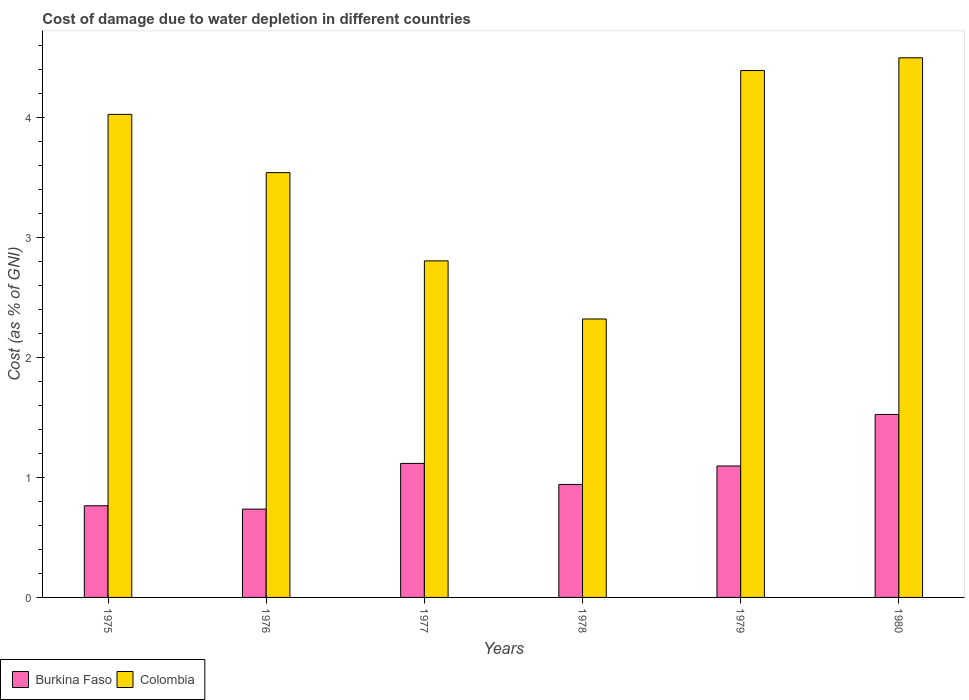Are the number of bars per tick equal to the number of legend labels?
Provide a short and direct response. Yes. Are the number of bars on each tick of the X-axis equal?
Make the answer very short. Yes. How many bars are there on the 1st tick from the left?
Provide a short and direct response. 2. What is the label of the 5th group of bars from the left?
Keep it short and to the point. 1979. In how many cases, is the number of bars for a given year not equal to the number of legend labels?
Your answer should be compact. 0. What is the cost of damage caused due to water depletion in Burkina Faso in 1977?
Ensure brevity in your answer.  1.12. Across all years, what is the maximum cost of damage caused due to water depletion in Burkina Faso?
Make the answer very short. 1.52. Across all years, what is the minimum cost of damage caused due to water depletion in Colombia?
Offer a terse response. 2.32. In which year was the cost of damage caused due to water depletion in Burkina Faso minimum?
Your response must be concise. 1976. What is the total cost of damage caused due to water depletion in Burkina Faso in the graph?
Give a very brief answer. 6.17. What is the difference between the cost of damage caused due to water depletion in Colombia in 1975 and that in 1977?
Offer a very short reply. 1.22. What is the difference between the cost of damage caused due to water depletion in Burkina Faso in 1976 and the cost of damage caused due to water depletion in Colombia in 1980?
Offer a terse response. -3.76. What is the average cost of damage caused due to water depletion in Colombia per year?
Your response must be concise. 3.59. In the year 1979, what is the difference between the cost of damage caused due to water depletion in Colombia and cost of damage caused due to water depletion in Burkina Faso?
Offer a terse response. 3.29. In how many years, is the cost of damage caused due to water depletion in Colombia greater than 3.4 %?
Your answer should be compact. 4. What is the ratio of the cost of damage caused due to water depletion in Colombia in 1979 to that in 1980?
Provide a short and direct response. 0.98. Is the difference between the cost of damage caused due to water depletion in Colombia in 1979 and 1980 greater than the difference between the cost of damage caused due to water depletion in Burkina Faso in 1979 and 1980?
Ensure brevity in your answer.  Yes. What is the difference between the highest and the second highest cost of damage caused due to water depletion in Colombia?
Provide a short and direct response. 0.11. What is the difference between the highest and the lowest cost of damage caused due to water depletion in Burkina Faso?
Keep it short and to the point. 0.79. In how many years, is the cost of damage caused due to water depletion in Burkina Faso greater than the average cost of damage caused due to water depletion in Burkina Faso taken over all years?
Offer a very short reply. 3. Is the sum of the cost of damage caused due to water depletion in Colombia in 1975 and 1976 greater than the maximum cost of damage caused due to water depletion in Burkina Faso across all years?
Your answer should be compact. Yes. What does the 1st bar from the left in 1977 represents?
Make the answer very short. Burkina Faso. Does the graph contain grids?
Ensure brevity in your answer.  No. Where does the legend appear in the graph?
Provide a short and direct response. Bottom left. How many legend labels are there?
Provide a short and direct response. 2. How are the legend labels stacked?
Your response must be concise. Horizontal. What is the title of the graph?
Make the answer very short. Cost of damage due to water depletion in different countries. Does "Slovenia" appear as one of the legend labels in the graph?
Give a very brief answer. No. What is the label or title of the X-axis?
Make the answer very short. Years. What is the label or title of the Y-axis?
Provide a succinct answer. Cost (as % of GNI). What is the Cost (as % of GNI) of Burkina Faso in 1975?
Keep it short and to the point. 0.76. What is the Cost (as % of GNI) of Colombia in 1975?
Ensure brevity in your answer.  4.02. What is the Cost (as % of GNI) of Burkina Faso in 1976?
Ensure brevity in your answer.  0.74. What is the Cost (as % of GNI) in Colombia in 1976?
Give a very brief answer. 3.54. What is the Cost (as % of GNI) in Burkina Faso in 1977?
Your answer should be very brief. 1.12. What is the Cost (as % of GNI) of Colombia in 1977?
Your answer should be compact. 2.8. What is the Cost (as % of GNI) in Burkina Faso in 1978?
Your answer should be very brief. 0.94. What is the Cost (as % of GNI) of Colombia in 1978?
Provide a short and direct response. 2.32. What is the Cost (as % of GNI) of Burkina Faso in 1979?
Make the answer very short. 1.09. What is the Cost (as % of GNI) in Colombia in 1979?
Make the answer very short. 4.39. What is the Cost (as % of GNI) in Burkina Faso in 1980?
Provide a succinct answer. 1.52. What is the Cost (as % of GNI) in Colombia in 1980?
Provide a succinct answer. 4.49. Across all years, what is the maximum Cost (as % of GNI) of Burkina Faso?
Give a very brief answer. 1.52. Across all years, what is the maximum Cost (as % of GNI) in Colombia?
Provide a short and direct response. 4.49. Across all years, what is the minimum Cost (as % of GNI) of Burkina Faso?
Offer a very short reply. 0.74. Across all years, what is the minimum Cost (as % of GNI) in Colombia?
Your answer should be very brief. 2.32. What is the total Cost (as % of GNI) in Burkina Faso in the graph?
Your answer should be very brief. 6.17. What is the total Cost (as % of GNI) in Colombia in the graph?
Your answer should be very brief. 21.56. What is the difference between the Cost (as % of GNI) in Burkina Faso in 1975 and that in 1976?
Make the answer very short. 0.03. What is the difference between the Cost (as % of GNI) of Colombia in 1975 and that in 1976?
Your answer should be very brief. 0.49. What is the difference between the Cost (as % of GNI) of Burkina Faso in 1975 and that in 1977?
Offer a terse response. -0.35. What is the difference between the Cost (as % of GNI) of Colombia in 1975 and that in 1977?
Provide a short and direct response. 1.22. What is the difference between the Cost (as % of GNI) of Burkina Faso in 1975 and that in 1978?
Provide a short and direct response. -0.18. What is the difference between the Cost (as % of GNI) of Colombia in 1975 and that in 1978?
Give a very brief answer. 1.7. What is the difference between the Cost (as % of GNI) of Burkina Faso in 1975 and that in 1979?
Make the answer very short. -0.33. What is the difference between the Cost (as % of GNI) of Colombia in 1975 and that in 1979?
Make the answer very short. -0.36. What is the difference between the Cost (as % of GNI) in Burkina Faso in 1975 and that in 1980?
Provide a short and direct response. -0.76. What is the difference between the Cost (as % of GNI) in Colombia in 1975 and that in 1980?
Provide a succinct answer. -0.47. What is the difference between the Cost (as % of GNI) of Burkina Faso in 1976 and that in 1977?
Provide a short and direct response. -0.38. What is the difference between the Cost (as % of GNI) in Colombia in 1976 and that in 1977?
Make the answer very short. 0.73. What is the difference between the Cost (as % of GNI) in Burkina Faso in 1976 and that in 1978?
Your response must be concise. -0.21. What is the difference between the Cost (as % of GNI) of Colombia in 1976 and that in 1978?
Ensure brevity in your answer.  1.22. What is the difference between the Cost (as % of GNI) in Burkina Faso in 1976 and that in 1979?
Offer a terse response. -0.36. What is the difference between the Cost (as % of GNI) of Colombia in 1976 and that in 1979?
Make the answer very short. -0.85. What is the difference between the Cost (as % of GNI) in Burkina Faso in 1976 and that in 1980?
Provide a succinct answer. -0.79. What is the difference between the Cost (as % of GNI) of Colombia in 1976 and that in 1980?
Offer a very short reply. -0.96. What is the difference between the Cost (as % of GNI) in Burkina Faso in 1977 and that in 1978?
Ensure brevity in your answer.  0.18. What is the difference between the Cost (as % of GNI) in Colombia in 1977 and that in 1978?
Give a very brief answer. 0.48. What is the difference between the Cost (as % of GNI) of Burkina Faso in 1977 and that in 1979?
Provide a short and direct response. 0.02. What is the difference between the Cost (as % of GNI) in Colombia in 1977 and that in 1979?
Make the answer very short. -1.58. What is the difference between the Cost (as % of GNI) in Burkina Faso in 1977 and that in 1980?
Make the answer very short. -0.41. What is the difference between the Cost (as % of GNI) of Colombia in 1977 and that in 1980?
Offer a terse response. -1.69. What is the difference between the Cost (as % of GNI) of Burkina Faso in 1978 and that in 1979?
Ensure brevity in your answer.  -0.15. What is the difference between the Cost (as % of GNI) in Colombia in 1978 and that in 1979?
Ensure brevity in your answer.  -2.07. What is the difference between the Cost (as % of GNI) in Burkina Faso in 1978 and that in 1980?
Your response must be concise. -0.58. What is the difference between the Cost (as % of GNI) of Colombia in 1978 and that in 1980?
Your response must be concise. -2.17. What is the difference between the Cost (as % of GNI) of Burkina Faso in 1979 and that in 1980?
Keep it short and to the point. -0.43. What is the difference between the Cost (as % of GNI) of Colombia in 1979 and that in 1980?
Offer a very short reply. -0.11. What is the difference between the Cost (as % of GNI) of Burkina Faso in 1975 and the Cost (as % of GNI) of Colombia in 1976?
Make the answer very short. -2.77. What is the difference between the Cost (as % of GNI) of Burkina Faso in 1975 and the Cost (as % of GNI) of Colombia in 1977?
Keep it short and to the point. -2.04. What is the difference between the Cost (as % of GNI) of Burkina Faso in 1975 and the Cost (as % of GNI) of Colombia in 1978?
Keep it short and to the point. -1.56. What is the difference between the Cost (as % of GNI) of Burkina Faso in 1975 and the Cost (as % of GNI) of Colombia in 1979?
Your answer should be very brief. -3.62. What is the difference between the Cost (as % of GNI) in Burkina Faso in 1975 and the Cost (as % of GNI) in Colombia in 1980?
Your response must be concise. -3.73. What is the difference between the Cost (as % of GNI) of Burkina Faso in 1976 and the Cost (as % of GNI) of Colombia in 1977?
Offer a terse response. -2.07. What is the difference between the Cost (as % of GNI) of Burkina Faso in 1976 and the Cost (as % of GNI) of Colombia in 1978?
Give a very brief answer. -1.58. What is the difference between the Cost (as % of GNI) in Burkina Faso in 1976 and the Cost (as % of GNI) in Colombia in 1979?
Offer a very short reply. -3.65. What is the difference between the Cost (as % of GNI) in Burkina Faso in 1976 and the Cost (as % of GNI) in Colombia in 1980?
Your answer should be compact. -3.76. What is the difference between the Cost (as % of GNI) of Burkina Faso in 1977 and the Cost (as % of GNI) of Colombia in 1978?
Offer a terse response. -1.2. What is the difference between the Cost (as % of GNI) of Burkina Faso in 1977 and the Cost (as % of GNI) of Colombia in 1979?
Make the answer very short. -3.27. What is the difference between the Cost (as % of GNI) in Burkina Faso in 1977 and the Cost (as % of GNI) in Colombia in 1980?
Your response must be concise. -3.38. What is the difference between the Cost (as % of GNI) of Burkina Faso in 1978 and the Cost (as % of GNI) of Colombia in 1979?
Provide a succinct answer. -3.45. What is the difference between the Cost (as % of GNI) in Burkina Faso in 1978 and the Cost (as % of GNI) in Colombia in 1980?
Ensure brevity in your answer.  -3.55. What is the difference between the Cost (as % of GNI) in Burkina Faso in 1979 and the Cost (as % of GNI) in Colombia in 1980?
Give a very brief answer. -3.4. What is the average Cost (as % of GNI) of Burkina Faso per year?
Keep it short and to the point. 1.03. What is the average Cost (as % of GNI) in Colombia per year?
Your response must be concise. 3.59. In the year 1975, what is the difference between the Cost (as % of GNI) of Burkina Faso and Cost (as % of GNI) of Colombia?
Make the answer very short. -3.26. In the year 1976, what is the difference between the Cost (as % of GNI) of Burkina Faso and Cost (as % of GNI) of Colombia?
Your response must be concise. -2.8. In the year 1977, what is the difference between the Cost (as % of GNI) of Burkina Faso and Cost (as % of GNI) of Colombia?
Provide a succinct answer. -1.69. In the year 1978, what is the difference between the Cost (as % of GNI) of Burkina Faso and Cost (as % of GNI) of Colombia?
Ensure brevity in your answer.  -1.38. In the year 1979, what is the difference between the Cost (as % of GNI) in Burkina Faso and Cost (as % of GNI) in Colombia?
Provide a succinct answer. -3.29. In the year 1980, what is the difference between the Cost (as % of GNI) of Burkina Faso and Cost (as % of GNI) of Colombia?
Your answer should be compact. -2.97. What is the ratio of the Cost (as % of GNI) in Burkina Faso in 1975 to that in 1976?
Make the answer very short. 1.04. What is the ratio of the Cost (as % of GNI) of Colombia in 1975 to that in 1976?
Give a very brief answer. 1.14. What is the ratio of the Cost (as % of GNI) in Burkina Faso in 1975 to that in 1977?
Provide a succinct answer. 0.68. What is the ratio of the Cost (as % of GNI) of Colombia in 1975 to that in 1977?
Your response must be concise. 1.44. What is the ratio of the Cost (as % of GNI) in Burkina Faso in 1975 to that in 1978?
Keep it short and to the point. 0.81. What is the ratio of the Cost (as % of GNI) in Colombia in 1975 to that in 1978?
Offer a very short reply. 1.73. What is the ratio of the Cost (as % of GNI) in Burkina Faso in 1975 to that in 1979?
Your answer should be very brief. 0.7. What is the ratio of the Cost (as % of GNI) of Colombia in 1975 to that in 1979?
Make the answer very short. 0.92. What is the ratio of the Cost (as % of GNI) in Burkina Faso in 1975 to that in 1980?
Provide a succinct answer. 0.5. What is the ratio of the Cost (as % of GNI) in Colombia in 1975 to that in 1980?
Your answer should be very brief. 0.9. What is the ratio of the Cost (as % of GNI) of Burkina Faso in 1976 to that in 1977?
Offer a terse response. 0.66. What is the ratio of the Cost (as % of GNI) in Colombia in 1976 to that in 1977?
Give a very brief answer. 1.26. What is the ratio of the Cost (as % of GNI) of Burkina Faso in 1976 to that in 1978?
Your answer should be very brief. 0.78. What is the ratio of the Cost (as % of GNI) of Colombia in 1976 to that in 1978?
Keep it short and to the point. 1.53. What is the ratio of the Cost (as % of GNI) in Burkina Faso in 1976 to that in 1979?
Provide a short and direct response. 0.67. What is the ratio of the Cost (as % of GNI) in Colombia in 1976 to that in 1979?
Offer a very short reply. 0.81. What is the ratio of the Cost (as % of GNI) in Burkina Faso in 1976 to that in 1980?
Ensure brevity in your answer.  0.48. What is the ratio of the Cost (as % of GNI) in Colombia in 1976 to that in 1980?
Provide a succinct answer. 0.79. What is the ratio of the Cost (as % of GNI) of Burkina Faso in 1977 to that in 1978?
Your response must be concise. 1.19. What is the ratio of the Cost (as % of GNI) in Colombia in 1977 to that in 1978?
Offer a terse response. 1.21. What is the ratio of the Cost (as % of GNI) of Burkina Faso in 1977 to that in 1979?
Offer a terse response. 1.02. What is the ratio of the Cost (as % of GNI) in Colombia in 1977 to that in 1979?
Provide a short and direct response. 0.64. What is the ratio of the Cost (as % of GNI) of Burkina Faso in 1977 to that in 1980?
Provide a short and direct response. 0.73. What is the ratio of the Cost (as % of GNI) of Colombia in 1977 to that in 1980?
Offer a terse response. 0.62. What is the ratio of the Cost (as % of GNI) in Burkina Faso in 1978 to that in 1979?
Provide a succinct answer. 0.86. What is the ratio of the Cost (as % of GNI) of Colombia in 1978 to that in 1979?
Your response must be concise. 0.53. What is the ratio of the Cost (as % of GNI) of Burkina Faso in 1978 to that in 1980?
Ensure brevity in your answer.  0.62. What is the ratio of the Cost (as % of GNI) in Colombia in 1978 to that in 1980?
Provide a short and direct response. 0.52. What is the ratio of the Cost (as % of GNI) in Burkina Faso in 1979 to that in 1980?
Offer a terse response. 0.72. What is the ratio of the Cost (as % of GNI) in Colombia in 1979 to that in 1980?
Your answer should be very brief. 0.98. What is the difference between the highest and the second highest Cost (as % of GNI) of Burkina Faso?
Your answer should be very brief. 0.41. What is the difference between the highest and the second highest Cost (as % of GNI) in Colombia?
Ensure brevity in your answer.  0.11. What is the difference between the highest and the lowest Cost (as % of GNI) of Burkina Faso?
Keep it short and to the point. 0.79. What is the difference between the highest and the lowest Cost (as % of GNI) of Colombia?
Provide a succinct answer. 2.17. 